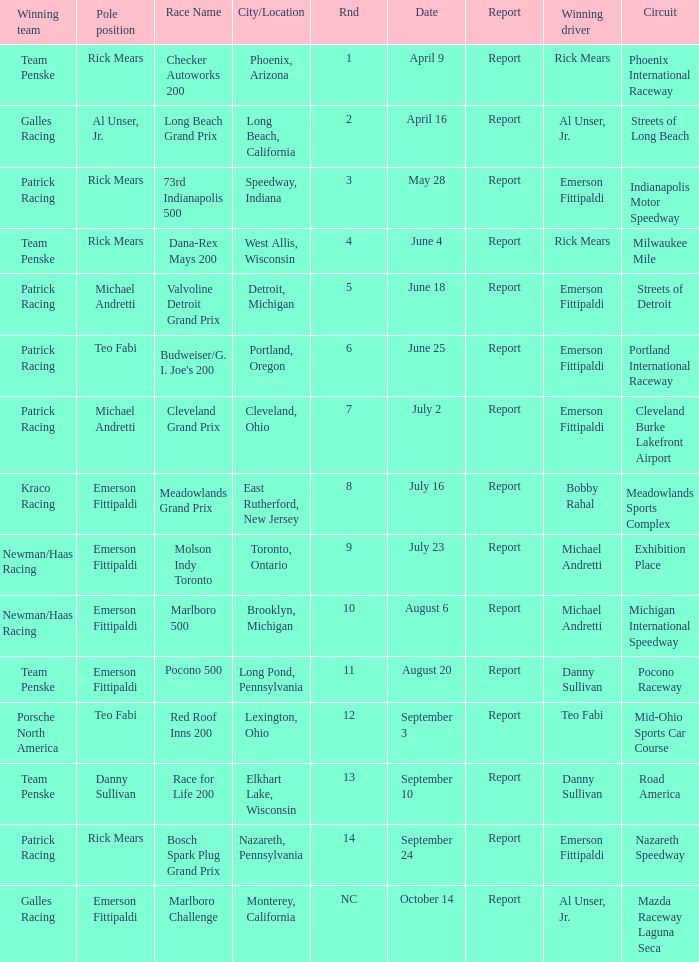What report was there for the porsche north america? Report. 